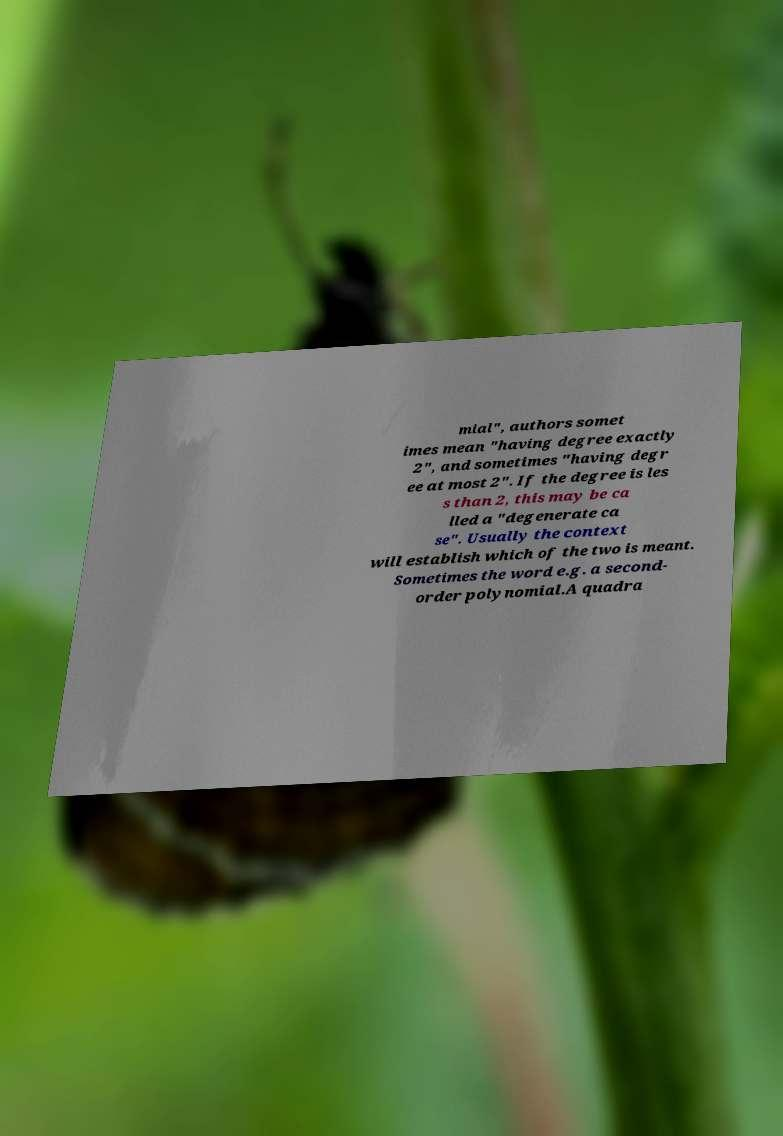I need the written content from this picture converted into text. Can you do that? mial", authors somet imes mean "having degree exactly 2", and sometimes "having degr ee at most 2". If the degree is les s than 2, this may be ca lled a "degenerate ca se". Usually the context will establish which of the two is meant. Sometimes the word e.g. a second- order polynomial.A quadra 